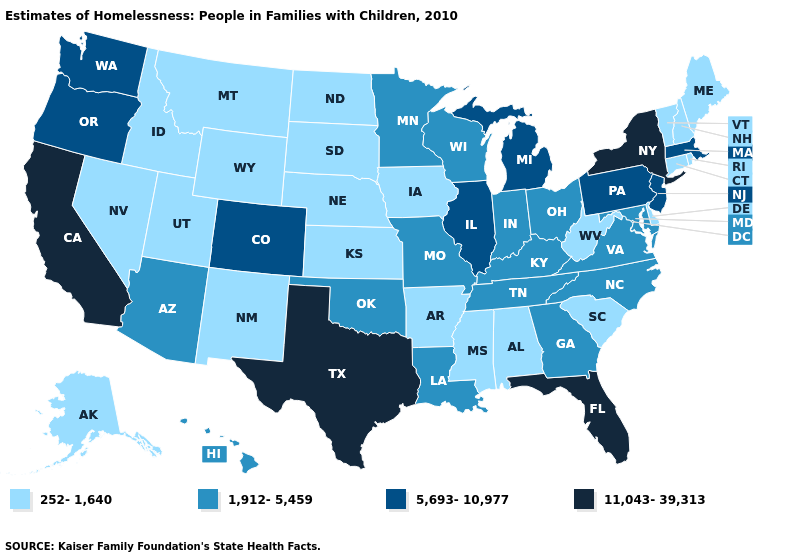Does the map have missing data?
Concise answer only. No. What is the lowest value in the MidWest?
Write a very short answer. 252-1,640. What is the highest value in states that border Virginia?
Quick response, please. 1,912-5,459. What is the value of Wyoming?
Answer briefly. 252-1,640. Name the states that have a value in the range 5,693-10,977?
Answer briefly. Colorado, Illinois, Massachusetts, Michigan, New Jersey, Oregon, Pennsylvania, Washington. What is the lowest value in the Northeast?
Concise answer only. 252-1,640. Among the states that border Delaware , which have the lowest value?
Keep it brief. Maryland. What is the lowest value in the USA?
Concise answer only. 252-1,640. Does Florida have the highest value in the USA?
Concise answer only. Yes. Does Alabama have the lowest value in the USA?
Answer briefly. Yes. Does Utah have a lower value than Colorado?
Concise answer only. Yes. How many symbols are there in the legend?
Be succinct. 4. What is the highest value in the Northeast ?
Quick response, please. 11,043-39,313. Among the states that border Arizona , does Colorado have the lowest value?
Keep it brief. No. 